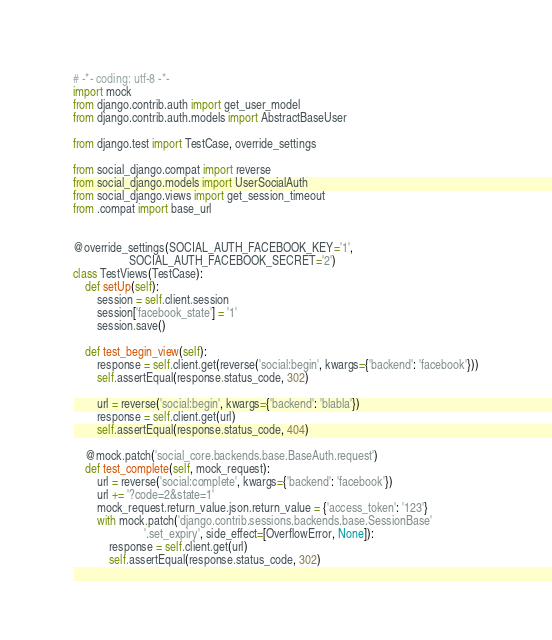<code> <loc_0><loc_0><loc_500><loc_500><_Python_># -*- coding: utf-8 -*-
import mock
from django.contrib.auth import get_user_model
from django.contrib.auth.models import AbstractBaseUser

from django.test import TestCase, override_settings

from social_django.compat import reverse
from social_django.models import UserSocialAuth
from social_django.views import get_session_timeout
from .compat import base_url


@override_settings(SOCIAL_AUTH_FACEBOOK_KEY='1',
                   SOCIAL_AUTH_FACEBOOK_SECRET='2')
class TestViews(TestCase):
    def setUp(self):
        session = self.client.session
        session['facebook_state'] = '1'
        session.save()

    def test_begin_view(self):
        response = self.client.get(reverse('social:begin', kwargs={'backend': 'facebook'}))
        self.assertEqual(response.status_code, 302)

        url = reverse('social:begin', kwargs={'backend': 'blabla'})
        response = self.client.get(url)
        self.assertEqual(response.status_code, 404)

    @mock.patch('social_core.backends.base.BaseAuth.request')
    def test_complete(self, mock_request):
        url = reverse('social:complete', kwargs={'backend': 'facebook'})
        url += '?code=2&state=1'
        mock_request.return_value.json.return_value = {'access_token': '123'}
        with mock.patch('django.contrib.sessions.backends.base.SessionBase'
                        '.set_expiry', side_effect=[OverflowError, None]):
            response = self.client.get(url)
            self.assertEqual(response.status_code, 302)</code> 